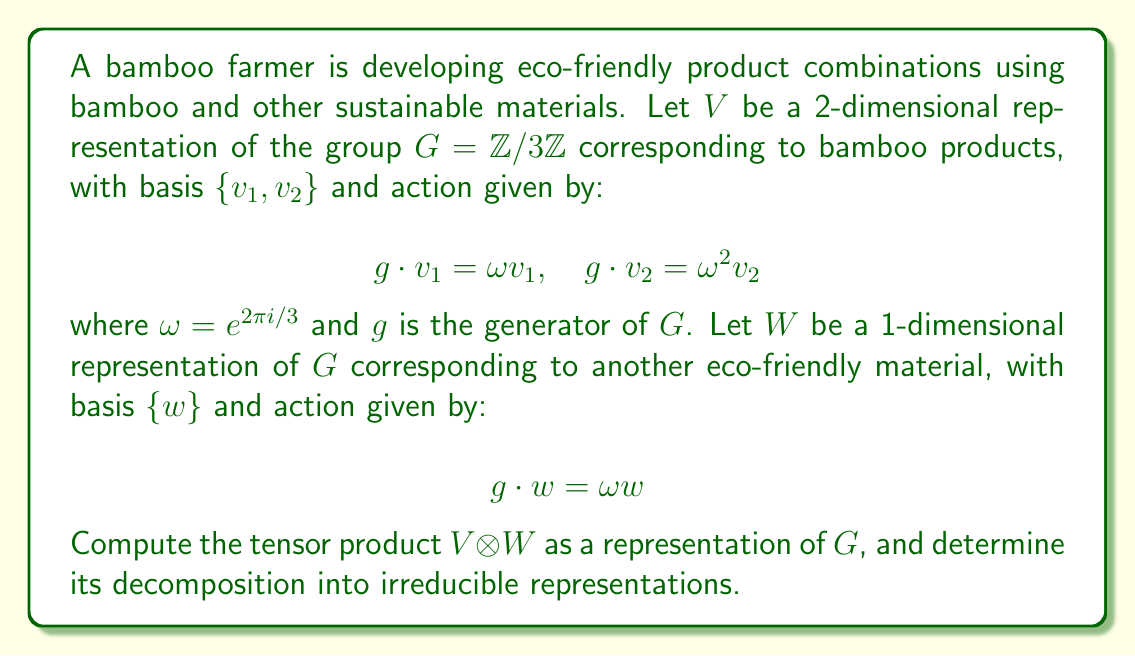Help me with this question. To solve this problem, we'll follow these steps:

1) First, we need to understand the tensor product $V \otimes W$. It will be a 2-dimensional representation with basis $\{v_1 \otimes w, v_2 \otimes w\}$.

2) We need to compute the action of $g$ on these basis elements:

   $g \cdot (v_1 \otimes w) = (g \cdot v_1) \otimes (g \cdot w) = (\omega v_1) \otimes (\omega w) = \omega^2 (v_1 \otimes w)$
   
   $g \cdot (v_2 \otimes w) = (g \cdot v_2) \otimes (g \cdot w) = (\omega^2 v_2) \otimes (\omega w) = (v_2 \otimes w)$

3) Now, we can write the matrix representation of $g$ acting on $V \otimes W$:

   $$g \mapsto \begin{pmatrix} \omega^2 & 0 \\ 0 & 1 \end{pmatrix}$$

4) To decompose this into irreducible representations, we need to recall the irreducible representations of $\mathbb{Z}/3\mathbb{Z}$. There are three 1-dimensional irreducible representations:

   $\rho_0: g \mapsto 1$
   $\rho_1: g \mapsto \omega$
   $\rho_2: g \mapsto \omega^2$

5) Looking at our matrix, we can see that $V \otimes W$ decomposes as the direct sum of $\rho_2$ (corresponding to the $\omega^2$ eigenvalue) and $\rho_0$ (corresponding to the 1 eigenvalue).

Therefore, $V \otimes W \cong \rho_2 \oplus \rho_0$ as representations of $G$.
Answer: $V \otimes W \cong \rho_2 \oplus \rho_0$ 